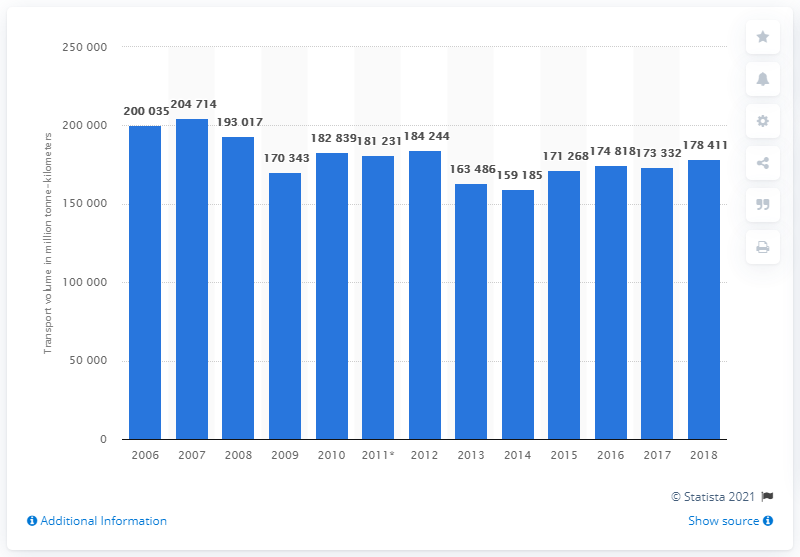Indicate a few pertinent items in this graphic. In 2018, the amount of freight transported within the UK was 178,411. 